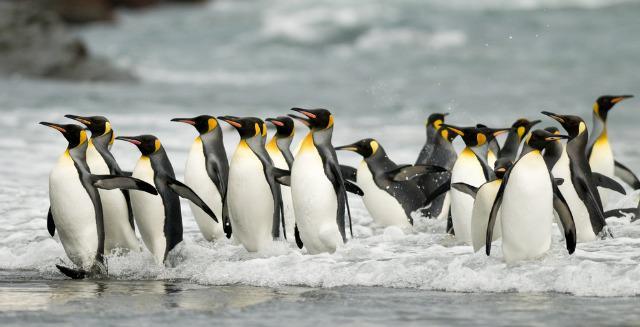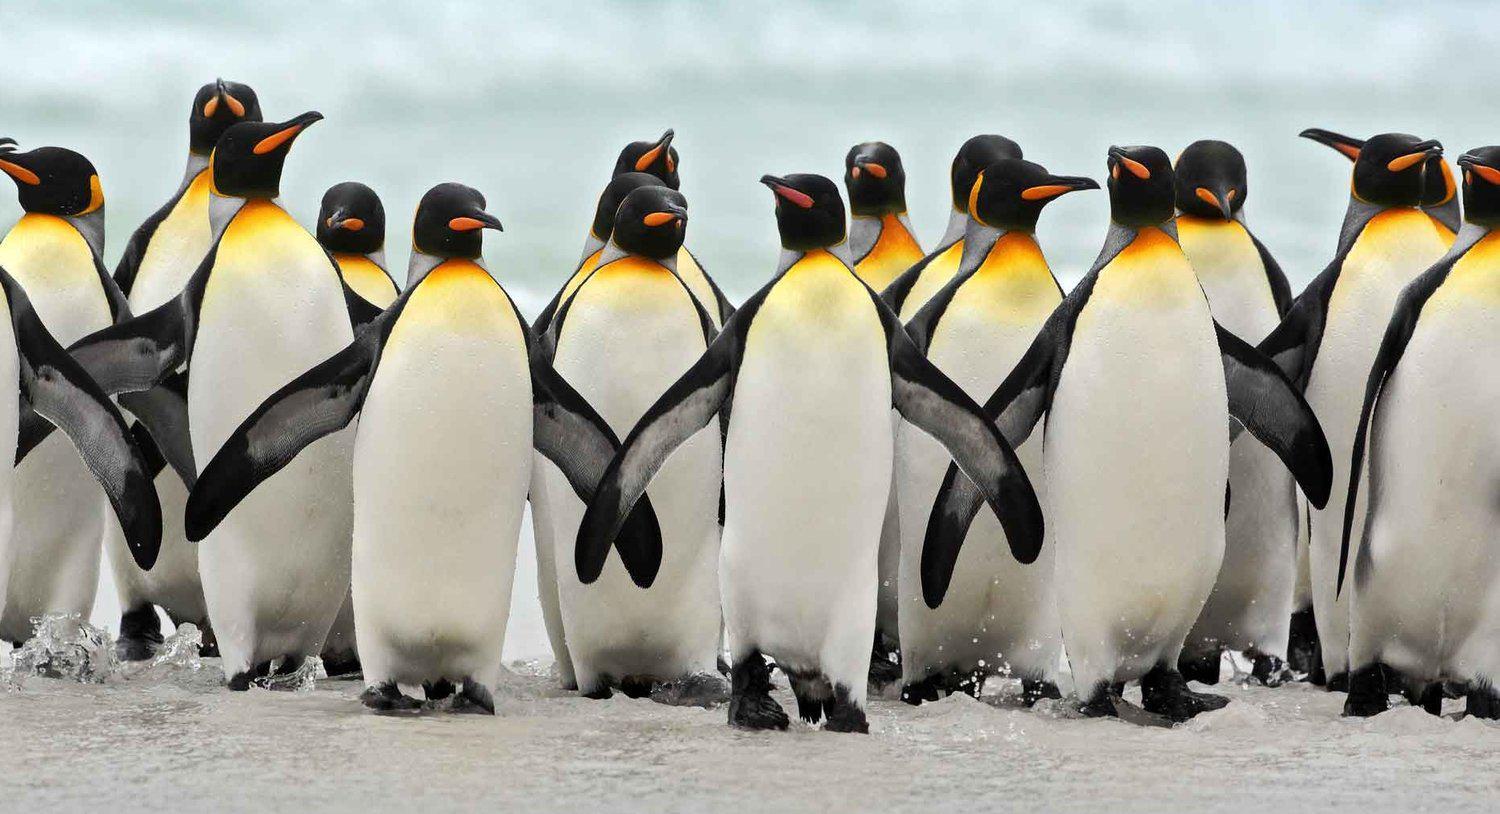The first image is the image on the left, the second image is the image on the right. Evaluate the accuracy of this statement regarding the images: "Images include penguins walking through water.". Is it true? Answer yes or no. Yes. The first image is the image on the left, the second image is the image on the right. For the images displayed, is the sentence "The penguins in at least one of the images are walking through the waves." factually correct? Answer yes or no. Yes. 